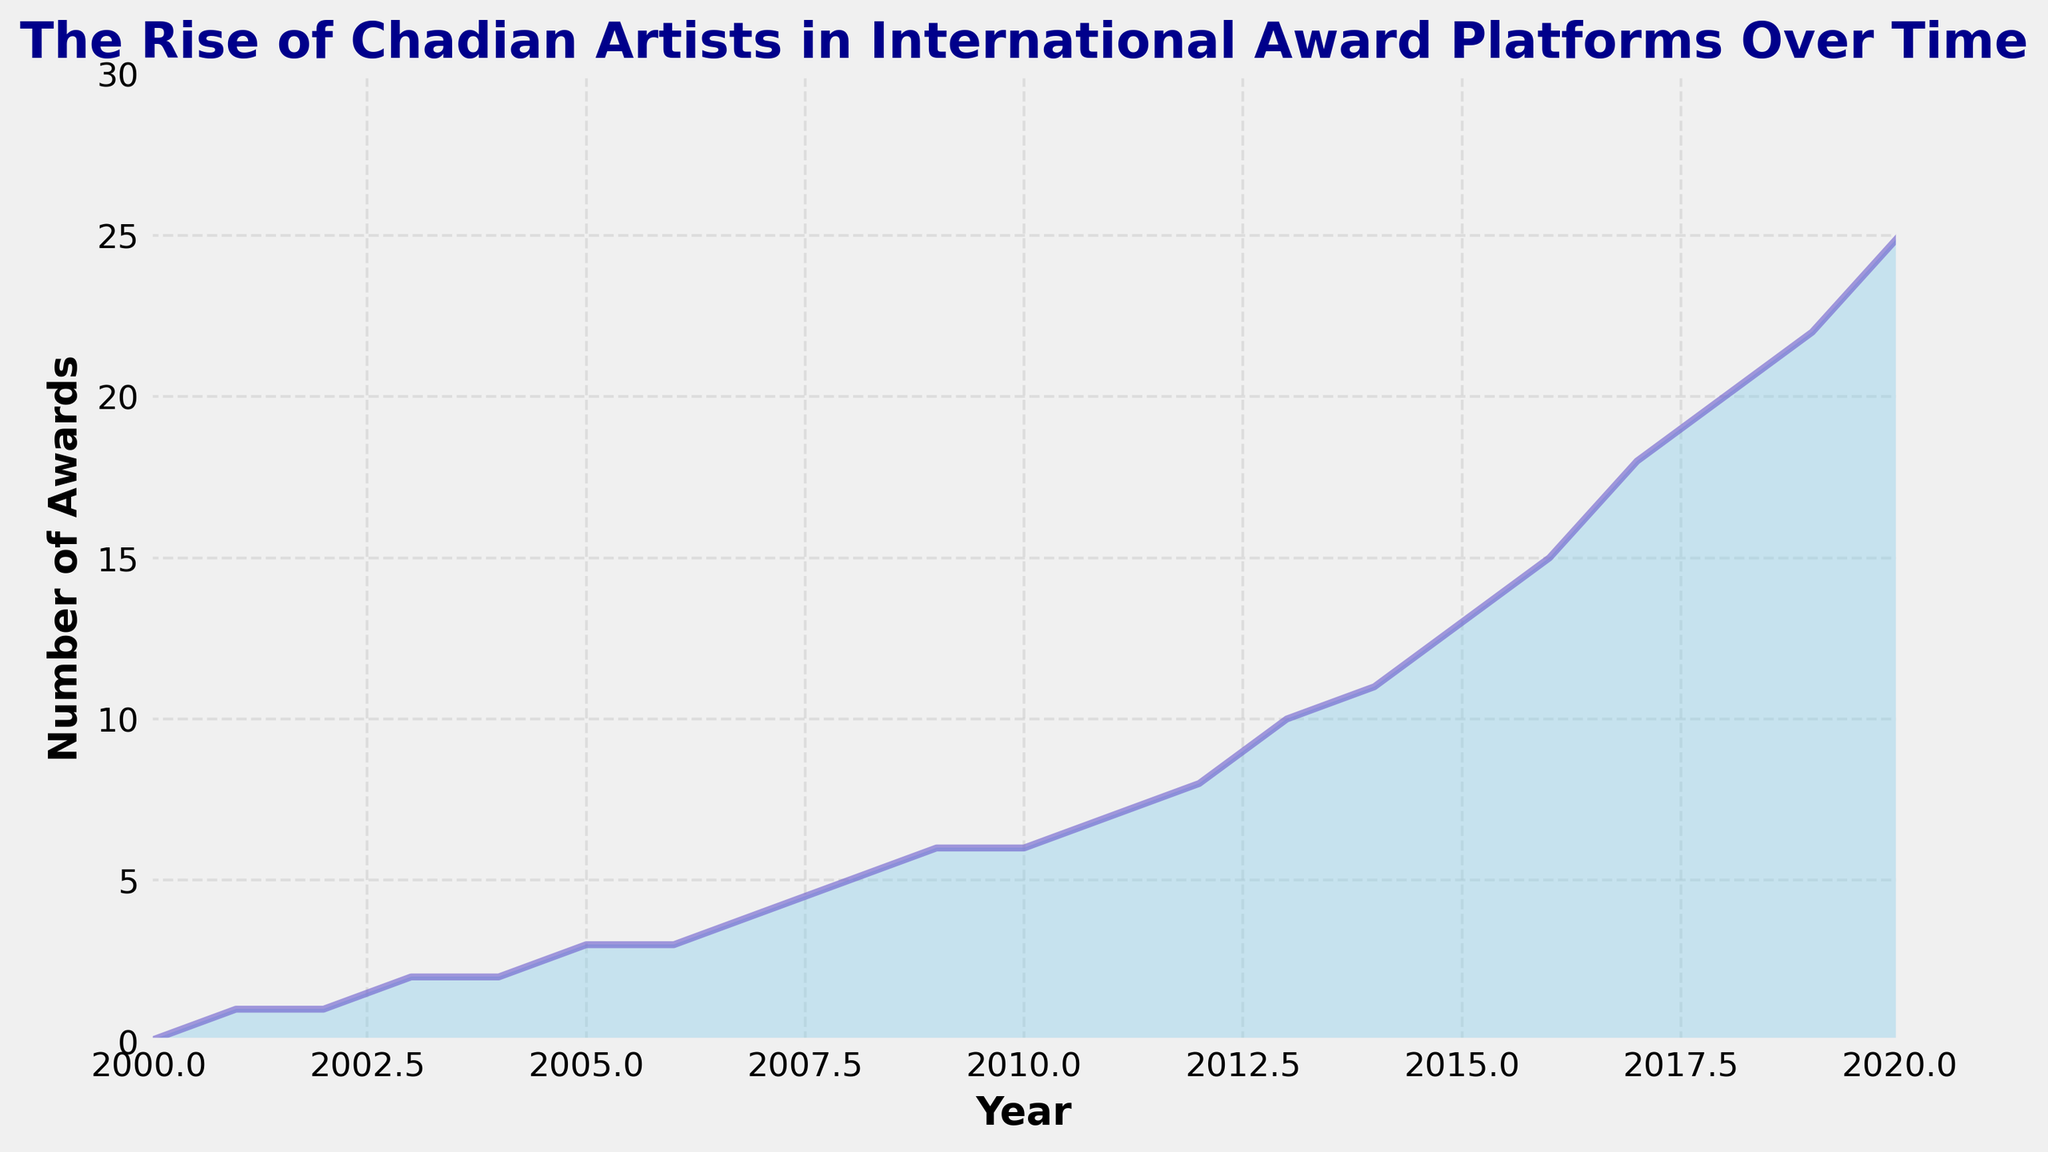What's the total number of awards won by Chadian artists from 2000 to 2010? Sum the number of awards each year from 2000 to 2010. This includes 0, 1, 1, 2, 2, 3, 3, 4, 5, 6, and 6, which add up to 33.
Answer: 33 In which year did Chadian artists first reach a double-digit number of awards? Look for the first instance where the number of awards reaches 10 or more. In 2013, the number of awards is 10.
Answer: 2013 How many awards were won in 2020 compared to 2010? In 2010, the number of awards was 6. In 2020, it was 25. Subtract 6 from 25 to find the increase.
Answer: 19 What is the average number of awards won per year from 2017 to 2020? The numbers for these years are 18, 20, 22, and 25. Sum these numbers (85) and divide by 4 (number of years). 85/4 = 21.25.
Answer: 21.25 Between 2007 and 2009, how did the number of awards change each year? In 2007, there were 4 awards. In 2008, 5 awards, and in 2009, 6 awards. The increase is +1 each year.
Answer: +1 each year Which year saw the greatest single-year increase in the number of awards? The largest increase observed is between 2016 to 2017, where the number of awards increased from 15 to 18 (an increase of 3).
Answer: 2017 Identify any periods where the number of awards did not increase from one year to the next. Check each year for any stagnant periods. From 2002 to 2003, and from 2004 to 2005, the awards did not increase.
Answer: 2002-2003, 2004-2005 What is the visual pattern of the area chart? The chart shows a continuous rise in the number of awards with the color intensifying from a lighter blue towards a darker shade as the number of awards increases.
Answer: Continuous rise, blue darkening By how many awards did the number of awards increase from 2015 to 2020? In 2015, there were 13 awards. By 2020, there were 25. Subtract 13 from 25 to get the increase: 25 - 13 = 12.
Answer: 12 